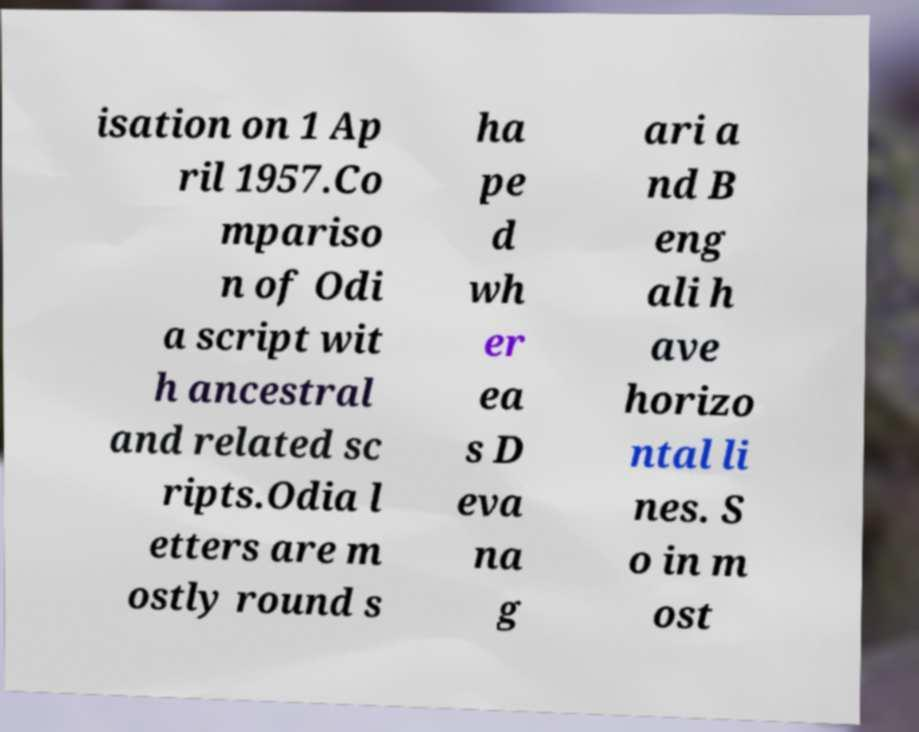Could you extract and type out the text from this image? isation on 1 Ap ril 1957.Co mpariso n of Odi a script wit h ancestral and related sc ripts.Odia l etters are m ostly round s ha pe d wh er ea s D eva na g ari a nd B eng ali h ave horizo ntal li nes. S o in m ost 